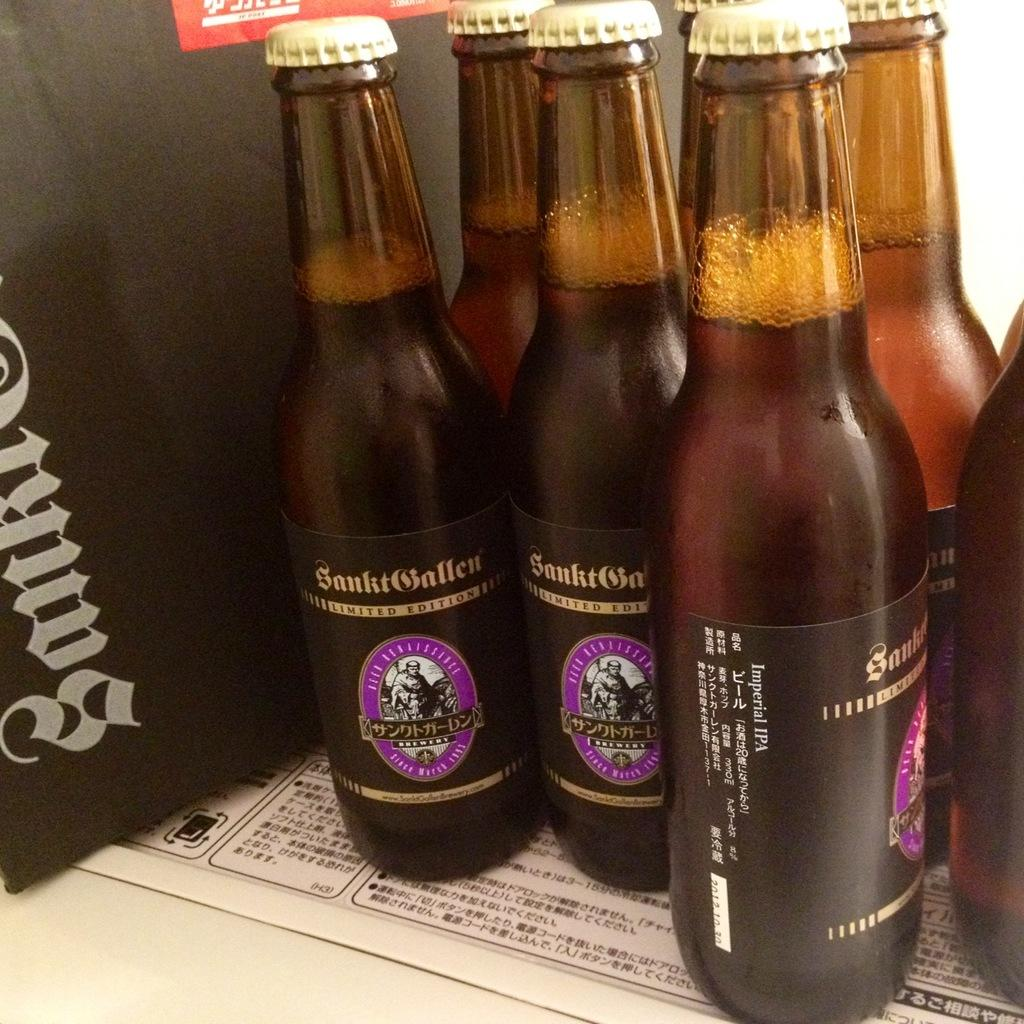<image>
Render a clear and concise summary of the photo. Seven bottles of SankitSnallen limited edition on top of a table. 